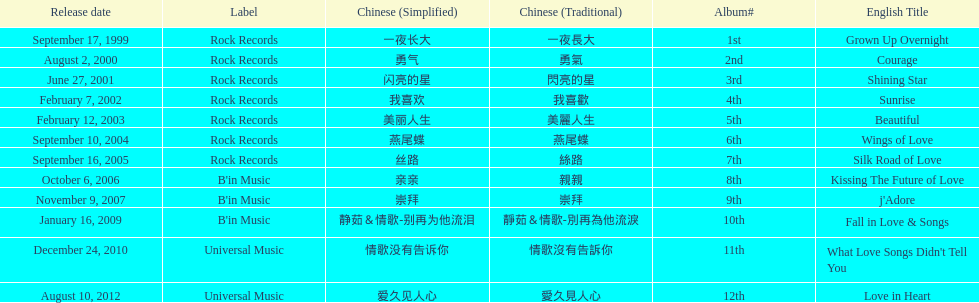What is the number of songs on rock records? 7. 